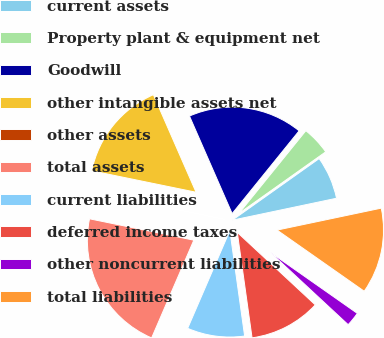Convert chart to OTSL. <chart><loc_0><loc_0><loc_500><loc_500><pie_chart><fcel>current assets<fcel>Property plant & equipment net<fcel>Goodwill<fcel>other intangible assets net<fcel>other assets<fcel>total assets<fcel>current liabilities<fcel>deferred income taxes<fcel>other noncurrent liabilities<fcel>total liabilities<nl><fcel>6.52%<fcel>4.35%<fcel>17.39%<fcel>15.21%<fcel>0.01%<fcel>21.73%<fcel>8.7%<fcel>10.87%<fcel>2.18%<fcel>13.04%<nl></chart> 